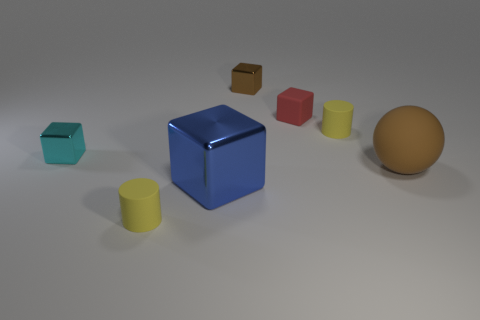Does the rubber sphere have the same color as the tiny cube that is behind the red rubber cube?
Your answer should be very brief. Yes. Are there the same number of metal blocks that are in front of the tiny matte block and metallic things behind the brown sphere?
Your answer should be very brief. Yes. What number of rubber spheres have the same size as the red object?
Offer a very short reply. 0. How many yellow objects are tiny shiny things or large rubber spheres?
Offer a terse response. 0. Is the number of small yellow things on the left side of the red cube the same as the number of tiny brown shiny blocks?
Offer a very short reply. Yes. What is the size of the cylinder that is in front of the brown rubber ball?
Make the answer very short. Small. What number of brown things have the same shape as the large blue object?
Give a very brief answer. 1. There is a object that is right of the tiny brown object and in front of the small cyan cube; what is its material?
Give a very brief answer. Rubber. Is the material of the large ball the same as the small red cube?
Your answer should be compact. Yes. What number of tiny green metal cylinders are there?
Your answer should be very brief. 0. 